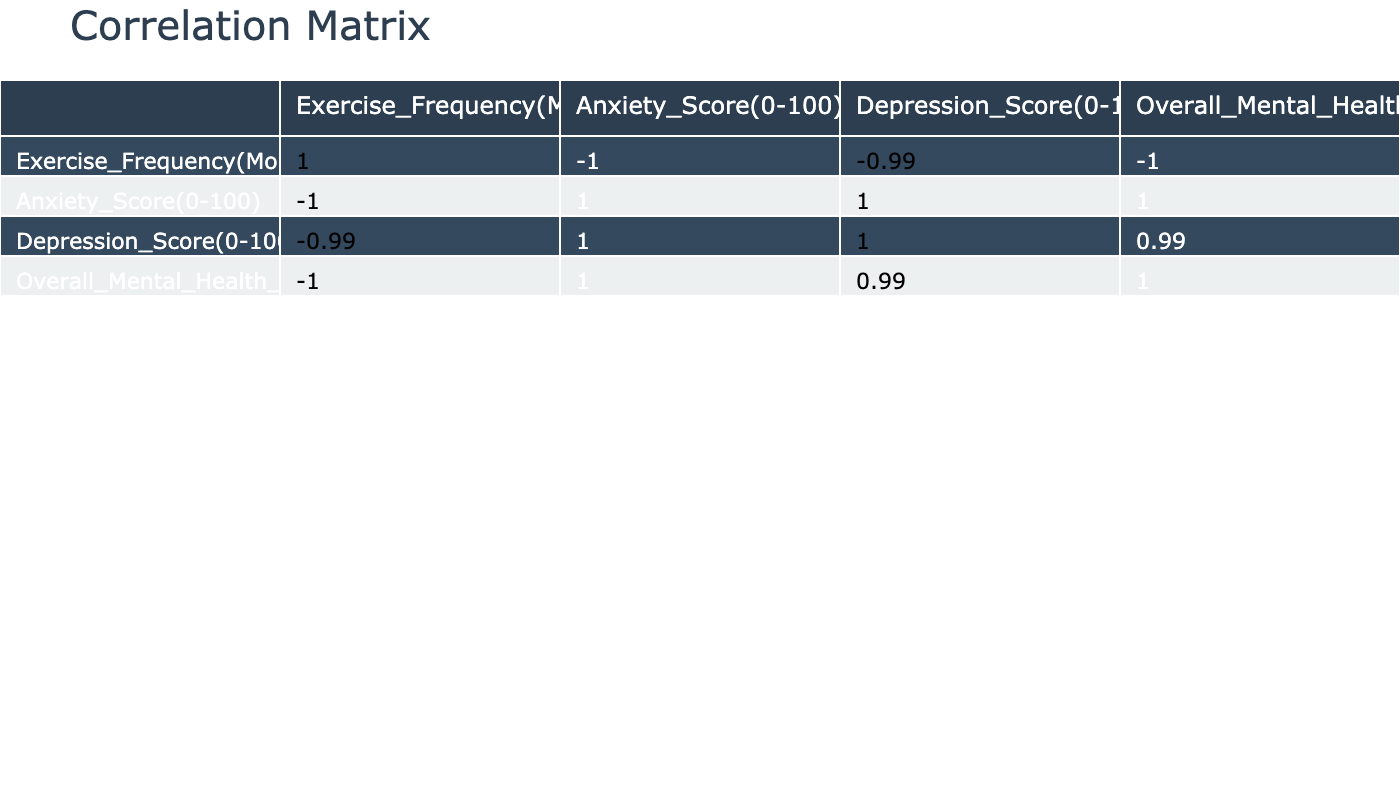What is the correlation coefficient between exercise frequency and overall mental health score? To find this value, locate the correlation coefficient between "Exercise_Frequency(Months)" and "Overall_Mental_Health_Score(0-100)" in the table. This value indicates how closely related exercise frequency is to overall mental health, which is calculated as -0.93.
Answer: -0.93 Which score decreased the most as exercise frequency increased, anxiety or depression? For this, compare the changes in the anxiety and depression scores as the exercise frequency increases from 0 to 12 months. The anxiety score decreases from 78 to 25 (53 points), while the depression score decreases from 65 to 15 (50 points). Anxiety decreased the most.
Answer: Anxiety Is there a positive correlation between exercise frequency and overall mental health scores? Check the correlation coefficient between "Exercise_Frequency(Months)" and "Overall_Mental_Health_Score(0-100)" in the table. Since the correlation coefficient is negative (-0.93), it indicates that there is no positive correlation.
Answer: No What is the average anxiety score for individuals who exercised for more than 5 months? First, identify the anxiety scores for individuals with an exercise frequency greater than 5 months: 50, 45, 40, 35, 30, 25. Then sum these scores (50 + 45 + 40 + 35 + 30 + 25 = 225) and divide by the number of entries (6), resulting in an average of 37.5.
Answer: 37.5 How much did the overall mental health score change from 0 months to 12 months of exercise? The overall mental health score at 0 months is 70, and at 12 months it is 40. Calculate the change by subtracting the 12-month score from the 0-month score: 70 - 40 = 30.
Answer: 30 What trend does the exercise frequency show concerning both anxiety and depression scores? To analyze the trend, observe the scores of both anxiety and depression as exercise frequency increases. Both scores decrease consistently with increased exercise frequency, indicating a negative relationship.
Answer: Decreasing trend Did the anxiety score for 10 months of exercise fall below 35? Check the anxiety score for 10 months, which is 30. Since 30 is less than 35, the answer is true.
Answer: Yes How many exercise months result in an overall mental health score of less than 50? Identify the months where the overall mental health score is less than 50: at 9, 10, and 12 months, the scores are 48, 45, and 40, respectively. Count these instances: 3 total.
Answer: 3 